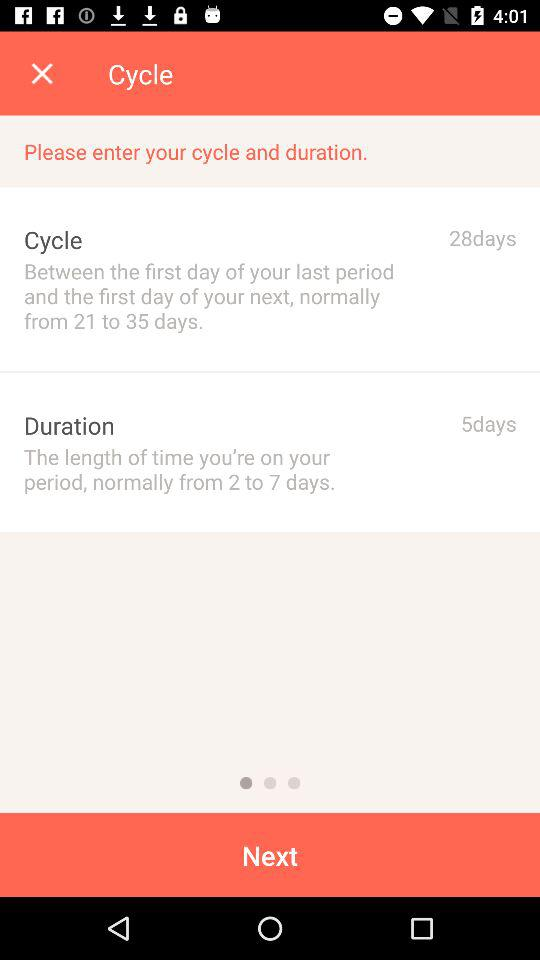How many more days does the user have in their cycle than their duration?
Answer the question using a single word or phrase. 23 